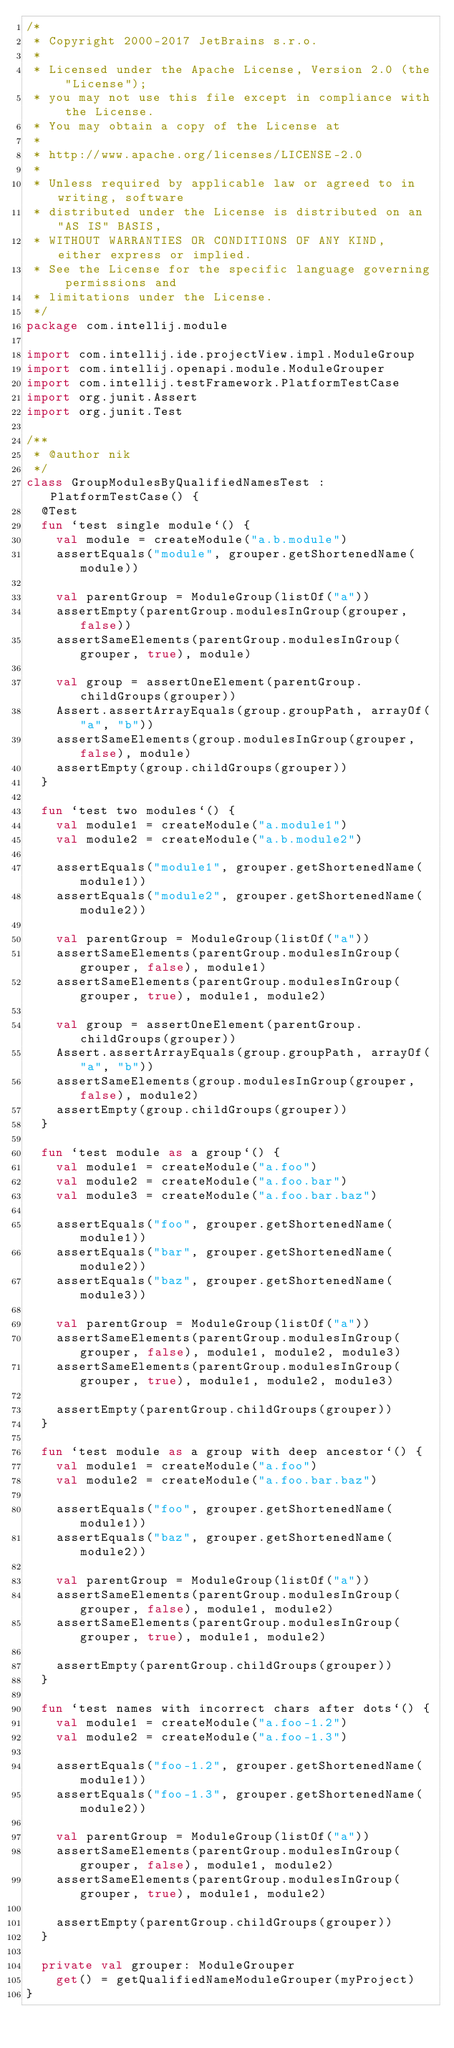<code> <loc_0><loc_0><loc_500><loc_500><_Kotlin_>/*
 * Copyright 2000-2017 JetBrains s.r.o.
 *
 * Licensed under the Apache License, Version 2.0 (the "License");
 * you may not use this file except in compliance with the License.
 * You may obtain a copy of the License at
 *
 * http://www.apache.org/licenses/LICENSE-2.0
 *
 * Unless required by applicable law or agreed to in writing, software
 * distributed under the License is distributed on an "AS IS" BASIS,
 * WITHOUT WARRANTIES OR CONDITIONS OF ANY KIND, either express or implied.
 * See the License for the specific language governing permissions and
 * limitations under the License.
 */
package com.intellij.module

import com.intellij.ide.projectView.impl.ModuleGroup
import com.intellij.openapi.module.ModuleGrouper
import com.intellij.testFramework.PlatformTestCase
import org.junit.Assert
import org.junit.Test

/**
 * @author nik
 */
class GroupModulesByQualifiedNamesTest : PlatformTestCase() {
  @Test
  fun `test single module`() {
    val module = createModule("a.b.module")
    assertEquals("module", grouper.getShortenedName(module))

    val parentGroup = ModuleGroup(listOf("a"))
    assertEmpty(parentGroup.modulesInGroup(grouper, false))
    assertSameElements(parentGroup.modulesInGroup(grouper, true), module)

    val group = assertOneElement(parentGroup.childGroups(grouper))
    Assert.assertArrayEquals(group.groupPath, arrayOf("a", "b"))
    assertSameElements(group.modulesInGroup(grouper, false), module)
    assertEmpty(group.childGroups(grouper))
  }

  fun `test two modules`() {
    val module1 = createModule("a.module1")
    val module2 = createModule("a.b.module2")

    assertEquals("module1", grouper.getShortenedName(module1))
    assertEquals("module2", grouper.getShortenedName(module2))

    val parentGroup = ModuleGroup(listOf("a"))
    assertSameElements(parentGroup.modulesInGroup(grouper, false), module1)
    assertSameElements(parentGroup.modulesInGroup(grouper, true), module1, module2)

    val group = assertOneElement(parentGroup.childGroups(grouper))
    Assert.assertArrayEquals(group.groupPath, arrayOf("a", "b"))
    assertSameElements(group.modulesInGroup(grouper, false), module2)
    assertEmpty(group.childGroups(grouper))
  }

  fun `test module as a group`() {
    val module1 = createModule("a.foo")
    val module2 = createModule("a.foo.bar")
    val module3 = createModule("a.foo.bar.baz")

    assertEquals("foo", grouper.getShortenedName(module1))
    assertEquals("bar", grouper.getShortenedName(module2))
    assertEquals("baz", grouper.getShortenedName(module3))

    val parentGroup = ModuleGroup(listOf("a"))
    assertSameElements(parentGroup.modulesInGroup(grouper, false), module1, module2, module3)
    assertSameElements(parentGroup.modulesInGroup(grouper, true), module1, module2, module3)

    assertEmpty(parentGroup.childGroups(grouper))
  }

  fun `test module as a group with deep ancestor`() {
    val module1 = createModule("a.foo")
    val module2 = createModule("a.foo.bar.baz")

    assertEquals("foo", grouper.getShortenedName(module1))
    assertEquals("baz", grouper.getShortenedName(module2))

    val parentGroup = ModuleGroup(listOf("a"))
    assertSameElements(parentGroup.modulesInGroup(grouper, false), module1, module2)
    assertSameElements(parentGroup.modulesInGroup(grouper, true), module1, module2)

    assertEmpty(parentGroup.childGroups(grouper))
  }

  fun `test names with incorrect chars after dots`() {
    val module1 = createModule("a.foo-1.2")
    val module2 = createModule("a.foo-1.3")

    assertEquals("foo-1.2", grouper.getShortenedName(module1))
    assertEquals("foo-1.3", grouper.getShortenedName(module2))

    val parentGroup = ModuleGroup(listOf("a"))
    assertSameElements(parentGroup.modulesInGroup(grouper, false), module1, module2)
    assertSameElements(parentGroup.modulesInGroup(grouper, true), module1, module2)

    assertEmpty(parentGroup.childGroups(grouper))
  }

  private val grouper: ModuleGrouper
    get() = getQualifiedNameModuleGrouper(myProject)
}
</code> 